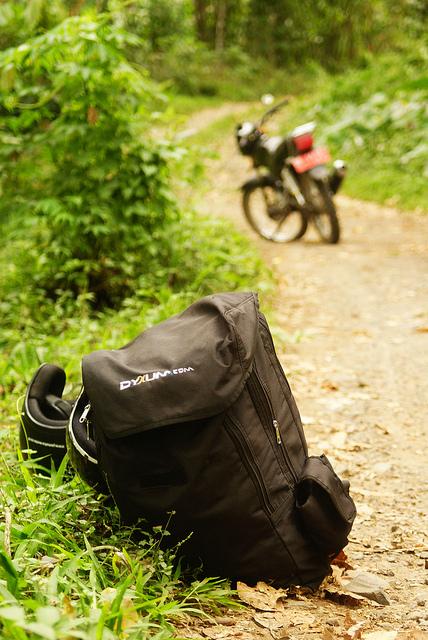What is the black object in the foreground?
Quick response, please. Backpack. Is the bag in the glass?
Quick response, please. No. What kind of vehicle can be seen in this photo?
Write a very short answer. Bike. 